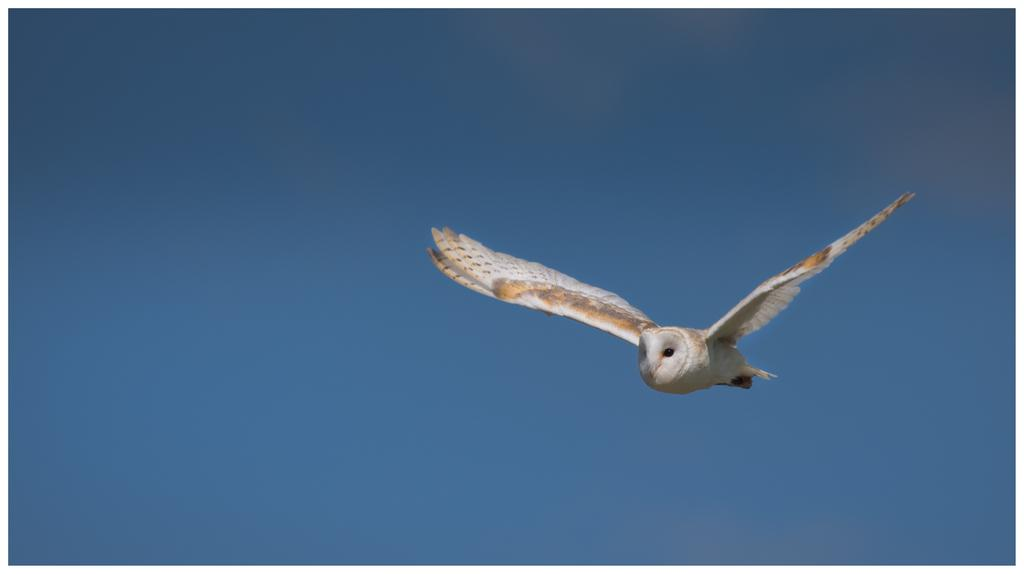What type of animal can be seen in the image? There is a bird in the image. What part of the natural environment is visible in the image? The sky is visible in the image. What type of poison is the bird using to attack its prey in the image? There is no indication in the image that the bird is using poison or attacking its prey. 